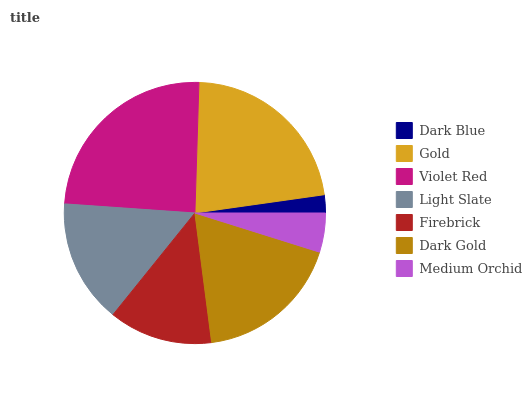Is Dark Blue the minimum?
Answer yes or no. Yes. Is Violet Red the maximum?
Answer yes or no. Yes. Is Gold the minimum?
Answer yes or no. No. Is Gold the maximum?
Answer yes or no. No. Is Gold greater than Dark Blue?
Answer yes or no. Yes. Is Dark Blue less than Gold?
Answer yes or no. Yes. Is Dark Blue greater than Gold?
Answer yes or no. No. Is Gold less than Dark Blue?
Answer yes or no. No. Is Light Slate the high median?
Answer yes or no. Yes. Is Light Slate the low median?
Answer yes or no. Yes. Is Medium Orchid the high median?
Answer yes or no. No. Is Firebrick the low median?
Answer yes or no. No. 